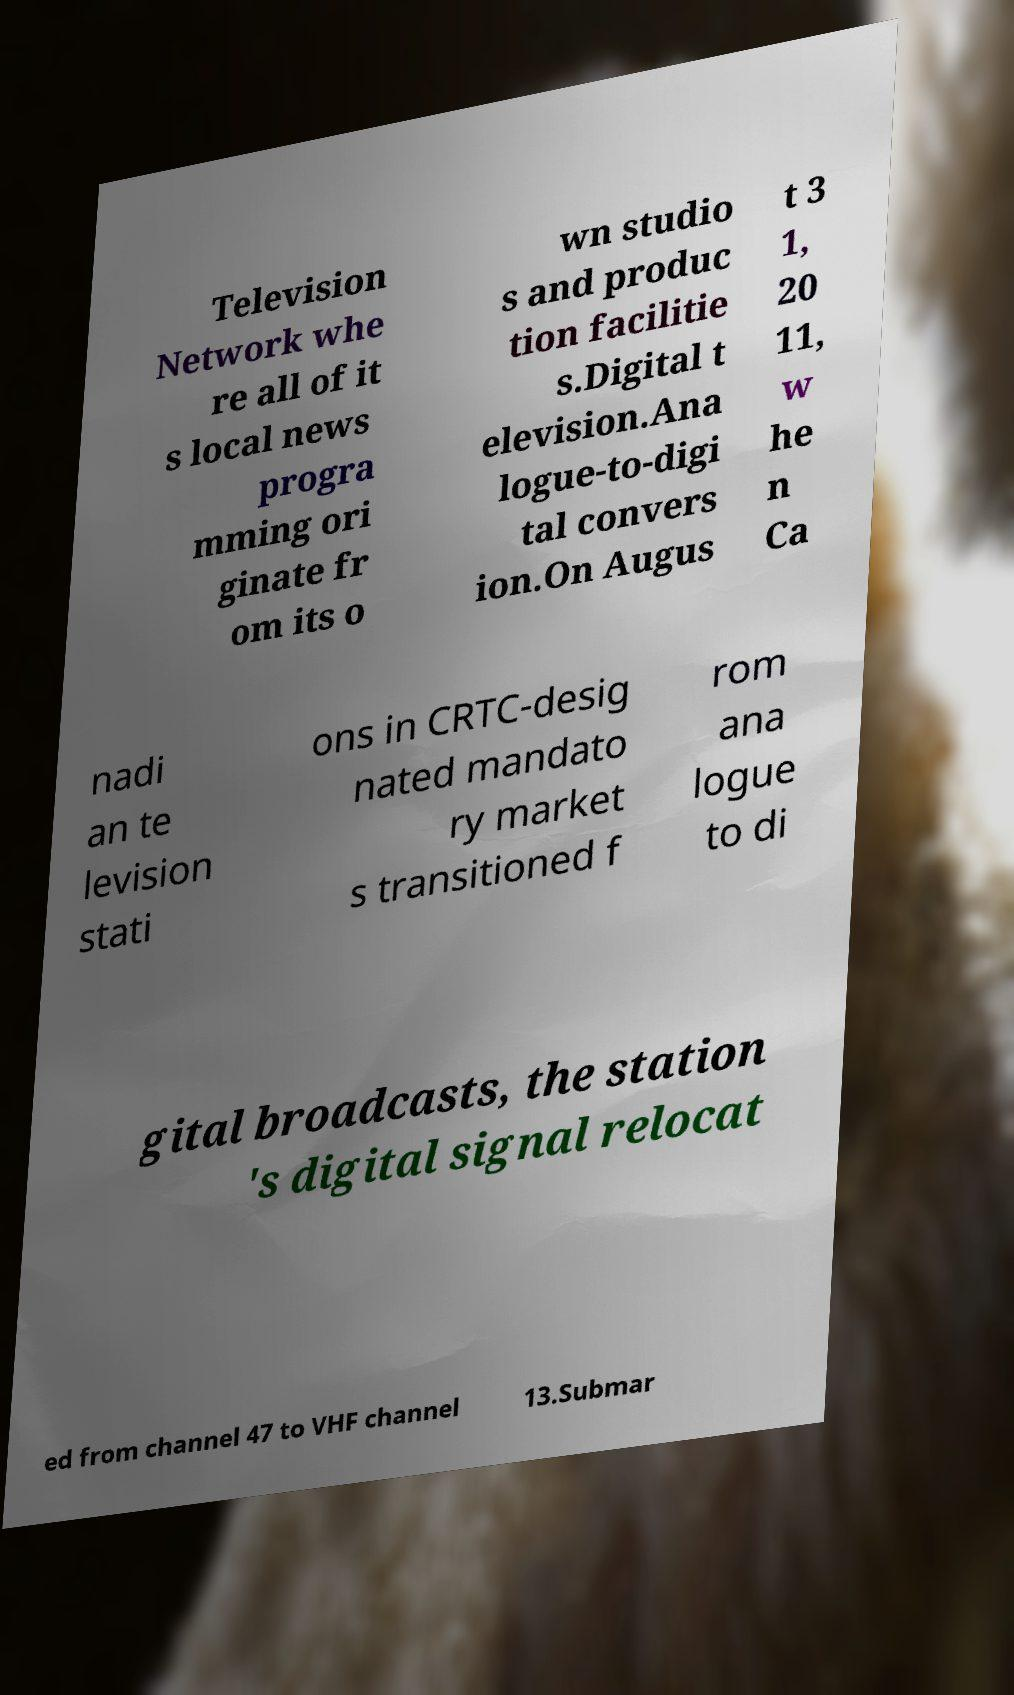Could you assist in decoding the text presented in this image and type it out clearly? Television Network whe re all of it s local news progra mming ori ginate fr om its o wn studio s and produc tion facilitie s.Digital t elevision.Ana logue-to-digi tal convers ion.On Augus t 3 1, 20 11, w he n Ca nadi an te levision stati ons in CRTC-desig nated mandato ry market s transitioned f rom ana logue to di gital broadcasts, the station 's digital signal relocat ed from channel 47 to VHF channel 13.Submar 